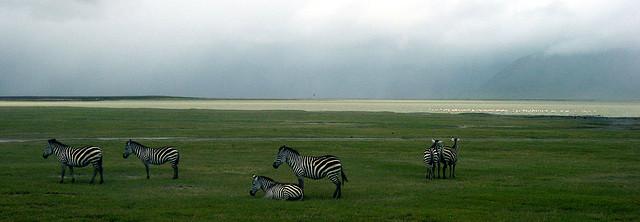What kind of weather is on the horizon?
Concise answer only. Cloudy. Is this a grassy area?
Write a very short answer. Yes. Which Zebra is lying down?
Short answer required. Middle. How many zebras are looking at the camera?
Answer briefly. 0. How many animals are in view?
Give a very brief answer. 6. 